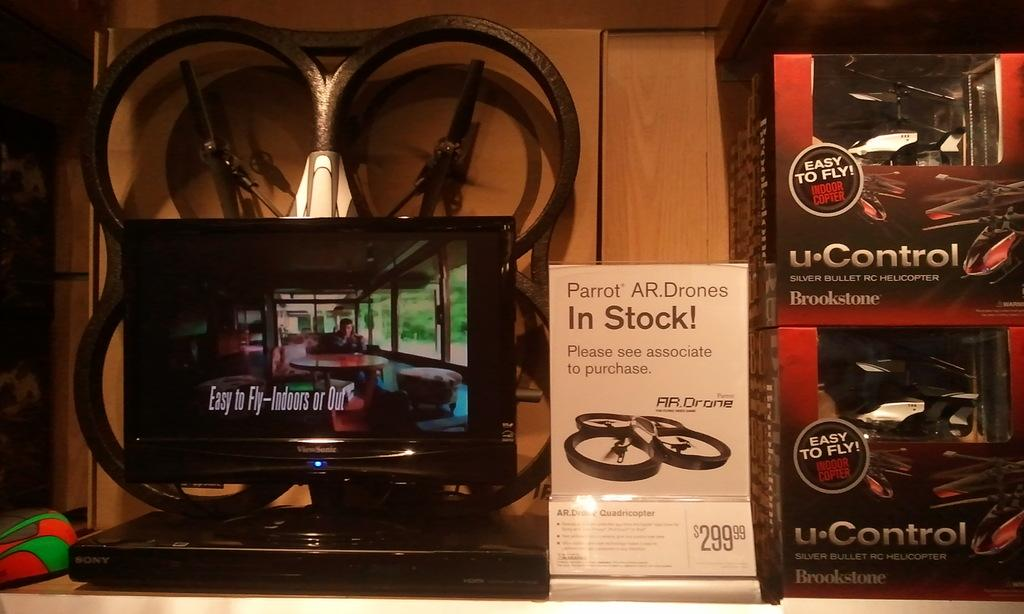<image>
Share a concise interpretation of the image provided. A display of different drones that can be flown indoors. 